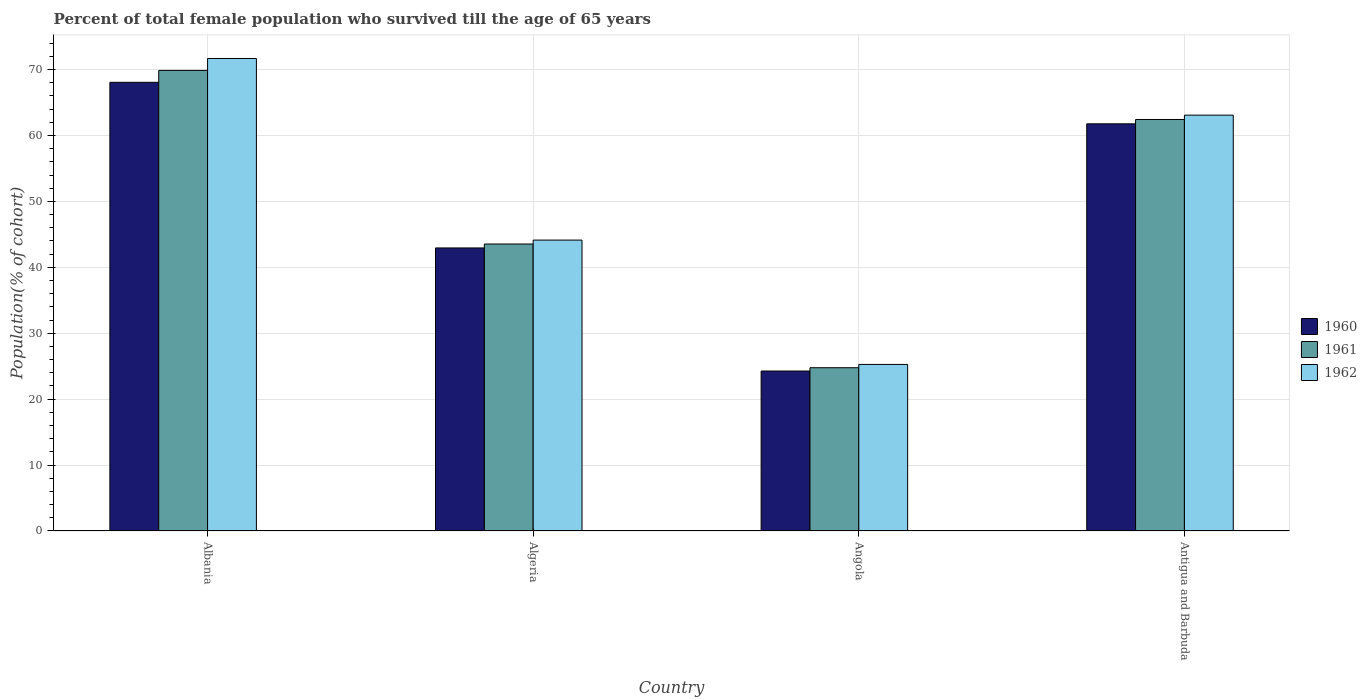Are the number of bars per tick equal to the number of legend labels?
Provide a short and direct response. Yes. How many bars are there on the 3rd tick from the right?
Offer a terse response. 3. What is the label of the 1st group of bars from the left?
Ensure brevity in your answer.  Albania. In how many cases, is the number of bars for a given country not equal to the number of legend labels?
Keep it short and to the point. 0. What is the percentage of total female population who survived till the age of 65 years in 1961 in Antigua and Barbuda?
Ensure brevity in your answer.  62.42. Across all countries, what is the maximum percentage of total female population who survived till the age of 65 years in 1960?
Give a very brief answer. 68.06. Across all countries, what is the minimum percentage of total female population who survived till the age of 65 years in 1962?
Keep it short and to the point. 25.27. In which country was the percentage of total female population who survived till the age of 65 years in 1960 maximum?
Offer a very short reply. Albania. In which country was the percentage of total female population who survived till the age of 65 years in 1960 minimum?
Your answer should be compact. Angola. What is the total percentage of total female population who survived till the age of 65 years in 1961 in the graph?
Give a very brief answer. 200.59. What is the difference between the percentage of total female population who survived till the age of 65 years in 1961 in Albania and that in Angola?
Your response must be concise. 45.1. What is the difference between the percentage of total female population who survived till the age of 65 years in 1961 in Algeria and the percentage of total female population who survived till the age of 65 years in 1962 in Albania?
Provide a succinct answer. -28.14. What is the average percentage of total female population who survived till the age of 65 years in 1960 per country?
Offer a very short reply. 49.26. What is the difference between the percentage of total female population who survived till the age of 65 years of/in 1962 and percentage of total female population who survived till the age of 65 years of/in 1961 in Angola?
Make the answer very short. 0.5. In how many countries, is the percentage of total female population who survived till the age of 65 years in 1962 greater than 46 %?
Your answer should be very brief. 2. What is the ratio of the percentage of total female population who survived till the age of 65 years in 1962 in Albania to that in Antigua and Barbuda?
Ensure brevity in your answer.  1.14. What is the difference between the highest and the second highest percentage of total female population who survived till the age of 65 years in 1961?
Your answer should be very brief. -26.34. What is the difference between the highest and the lowest percentage of total female population who survived till the age of 65 years in 1961?
Your response must be concise. 45.1. In how many countries, is the percentage of total female population who survived till the age of 65 years in 1961 greater than the average percentage of total female population who survived till the age of 65 years in 1961 taken over all countries?
Offer a very short reply. 2. Is the sum of the percentage of total female population who survived till the age of 65 years in 1960 in Albania and Algeria greater than the maximum percentage of total female population who survived till the age of 65 years in 1961 across all countries?
Provide a succinct answer. Yes. What does the 1st bar from the right in Antigua and Barbuda represents?
Your answer should be very brief. 1962. Is it the case that in every country, the sum of the percentage of total female population who survived till the age of 65 years in 1961 and percentage of total female population who survived till the age of 65 years in 1962 is greater than the percentage of total female population who survived till the age of 65 years in 1960?
Provide a short and direct response. Yes. How many bars are there?
Offer a very short reply. 12. How many countries are there in the graph?
Ensure brevity in your answer.  4. What is the difference between two consecutive major ticks on the Y-axis?
Offer a very short reply. 10. Does the graph contain any zero values?
Your answer should be very brief. No. What is the title of the graph?
Your response must be concise. Percent of total female population who survived till the age of 65 years. Does "1964" appear as one of the legend labels in the graph?
Your answer should be very brief. No. What is the label or title of the Y-axis?
Provide a succinct answer. Population(% of cohort). What is the Population(% of cohort) of 1960 in Albania?
Give a very brief answer. 68.06. What is the Population(% of cohort) in 1961 in Albania?
Your response must be concise. 69.87. What is the Population(% of cohort) of 1962 in Albania?
Your answer should be compact. 71.67. What is the Population(% of cohort) in 1960 in Algeria?
Offer a very short reply. 42.94. What is the Population(% of cohort) of 1961 in Algeria?
Your answer should be very brief. 43.53. What is the Population(% of cohort) in 1962 in Algeria?
Make the answer very short. 44.13. What is the Population(% of cohort) in 1960 in Angola?
Offer a terse response. 24.27. What is the Population(% of cohort) of 1961 in Angola?
Your answer should be compact. 24.77. What is the Population(% of cohort) in 1962 in Angola?
Offer a terse response. 25.27. What is the Population(% of cohort) in 1960 in Antigua and Barbuda?
Offer a terse response. 61.77. What is the Population(% of cohort) in 1961 in Antigua and Barbuda?
Provide a succinct answer. 62.42. What is the Population(% of cohort) in 1962 in Antigua and Barbuda?
Give a very brief answer. 63.08. Across all countries, what is the maximum Population(% of cohort) of 1960?
Your answer should be very brief. 68.06. Across all countries, what is the maximum Population(% of cohort) of 1961?
Give a very brief answer. 69.87. Across all countries, what is the maximum Population(% of cohort) in 1962?
Offer a very short reply. 71.67. Across all countries, what is the minimum Population(% of cohort) of 1960?
Your response must be concise. 24.27. Across all countries, what is the minimum Population(% of cohort) in 1961?
Your answer should be compact. 24.77. Across all countries, what is the minimum Population(% of cohort) in 1962?
Keep it short and to the point. 25.27. What is the total Population(% of cohort) in 1960 in the graph?
Provide a short and direct response. 197.04. What is the total Population(% of cohort) of 1961 in the graph?
Provide a short and direct response. 200.59. What is the total Population(% of cohort) of 1962 in the graph?
Your answer should be compact. 204.15. What is the difference between the Population(% of cohort) of 1960 in Albania and that in Algeria?
Your answer should be very brief. 25.13. What is the difference between the Population(% of cohort) of 1961 in Albania and that in Algeria?
Your answer should be very brief. 26.34. What is the difference between the Population(% of cohort) of 1962 in Albania and that in Algeria?
Offer a very short reply. 27.54. What is the difference between the Population(% of cohort) of 1960 in Albania and that in Angola?
Give a very brief answer. 43.8. What is the difference between the Population(% of cohort) in 1961 in Albania and that in Angola?
Provide a short and direct response. 45.1. What is the difference between the Population(% of cohort) of 1962 in Albania and that in Angola?
Your response must be concise. 46.41. What is the difference between the Population(% of cohort) in 1960 in Albania and that in Antigua and Barbuda?
Make the answer very short. 6.3. What is the difference between the Population(% of cohort) in 1961 in Albania and that in Antigua and Barbuda?
Provide a succinct answer. 7.45. What is the difference between the Population(% of cohort) in 1962 in Albania and that in Antigua and Barbuda?
Give a very brief answer. 8.59. What is the difference between the Population(% of cohort) in 1960 in Algeria and that in Angola?
Give a very brief answer. 18.67. What is the difference between the Population(% of cohort) of 1961 in Algeria and that in Angola?
Offer a terse response. 18.77. What is the difference between the Population(% of cohort) of 1962 in Algeria and that in Angola?
Ensure brevity in your answer.  18.86. What is the difference between the Population(% of cohort) of 1960 in Algeria and that in Antigua and Barbuda?
Make the answer very short. -18.83. What is the difference between the Population(% of cohort) in 1961 in Algeria and that in Antigua and Barbuda?
Make the answer very short. -18.89. What is the difference between the Population(% of cohort) in 1962 in Algeria and that in Antigua and Barbuda?
Your response must be concise. -18.95. What is the difference between the Population(% of cohort) in 1960 in Angola and that in Antigua and Barbuda?
Ensure brevity in your answer.  -37.5. What is the difference between the Population(% of cohort) of 1961 in Angola and that in Antigua and Barbuda?
Your answer should be compact. -37.66. What is the difference between the Population(% of cohort) of 1962 in Angola and that in Antigua and Barbuda?
Ensure brevity in your answer.  -37.82. What is the difference between the Population(% of cohort) in 1960 in Albania and the Population(% of cohort) in 1961 in Algeria?
Ensure brevity in your answer.  24.53. What is the difference between the Population(% of cohort) in 1960 in Albania and the Population(% of cohort) in 1962 in Algeria?
Provide a succinct answer. 23.93. What is the difference between the Population(% of cohort) in 1961 in Albania and the Population(% of cohort) in 1962 in Algeria?
Ensure brevity in your answer.  25.74. What is the difference between the Population(% of cohort) in 1960 in Albania and the Population(% of cohort) in 1961 in Angola?
Keep it short and to the point. 43.3. What is the difference between the Population(% of cohort) in 1960 in Albania and the Population(% of cohort) in 1962 in Angola?
Your response must be concise. 42.8. What is the difference between the Population(% of cohort) in 1961 in Albania and the Population(% of cohort) in 1962 in Angola?
Make the answer very short. 44.6. What is the difference between the Population(% of cohort) in 1960 in Albania and the Population(% of cohort) in 1961 in Antigua and Barbuda?
Provide a succinct answer. 5.64. What is the difference between the Population(% of cohort) in 1960 in Albania and the Population(% of cohort) in 1962 in Antigua and Barbuda?
Your answer should be very brief. 4.98. What is the difference between the Population(% of cohort) in 1961 in Albania and the Population(% of cohort) in 1962 in Antigua and Barbuda?
Offer a very short reply. 6.79. What is the difference between the Population(% of cohort) in 1960 in Algeria and the Population(% of cohort) in 1961 in Angola?
Give a very brief answer. 18.17. What is the difference between the Population(% of cohort) in 1960 in Algeria and the Population(% of cohort) in 1962 in Angola?
Offer a terse response. 17.67. What is the difference between the Population(% of cohort) of 1961 in Algeria and the Population(% of cohort) of 1962 in Angola?
Your answer should be very brief. 18.27. What is the difference between the Population(% of cohort) of 1960 in Algeria and the Population(% of cohort) of 1961 in Antigua and Barbuda?
Ensure brevity in your answer.  -19.49. What is the difference between the Population(% of cohort) of 1960 in Algeria and the Population(% of cohort) of 1962 in Antigua and Barbuda?
Give a very brief answer. -20.14. What is the difference between the Population(% of cohort) of 1961 in Algeria and the Population(% of cohort) of 1962 in Antigua and Barbuda?
Your response must be concise. -19.55. What is the difference between the Population(% of cohort) of 1960 in Angola and the Population(% of cohort) of 1961 in Antigua and Barbuda?
Your answer should be very brief. -38.16. What is the difference between the Population(% of cohort) in 1960 in Angola and the Population(% of cohort) in 1962 in Antigua and Barbuda?
Your answer should be very brief. -38.82. What is the difference between the Population(% of cohort) of 1961 in Angola and the Population(% of cohort) of 1962 in Antigua and Barbuda?
Your response must be concise. -38.32. What is the average Population(% of cohort) of 1960 per country?
Your answer should be compact. 49.26. What is the average Population(% of cohort) in 1961 per country?
Your response must be concise. 50.15. What is the average Population(% of cohort) of 1962 per country?
Provide a short and direct response. 51.04. What is the difference between the Population(% of cohort) of 1960 and Population(% of cohort) of 1961 in Albania?
Make the answer very short. -1.81. What is the difference between the Population(% of cohort) in 1960 and Population(% of cohort) in 1962 in Albania?
Offer a terse response. -3.61. What is the difference between the Population(% of cohort) of 1961 and Population(% of cohort) of 1962 in Albania?
Provide a short and direct response. -1.81. What is the difference between the Population(% of cohort) of 1960 and Population(% of cohort) of 1961 in Algeria?
Give a very brief answer. -0.6. What is the difference between the Population(% of cohort) in 1960 and Population(% of cohort) in 1962 in Algeria?
Provide a succinct answer. -1.19. What is the difference between the Population(% of cohort) of 1961 and Population(% of cohort) of 1962 in Algeria?
Your answer should be very brief. -0.6. What is the difference between the Population(% of cohort) of 1960 and Population(% of cohort) of 1961 in Angola?
Make the answer very short. -0.5. What is the difference between the Population(% of cohort) in 1960 and Population(% of cohort) in 1962 in Angola?
Provide a succinct answer. -1. What is the difference between the Population(% of cohort) in 1961 and Population(% of cohort) in 1962 in Angola?
Your response must be concise. -0.5. What is the difference between the Population(% of cohort) in 1960 and Population(% of cohort) in 1961 in Antigua and Barbuda?
Provide a short and direct response. -0.66. What is the difference between the Population(% of cohort) in 1960 and Population(% of cohort) in 1962 in Antigua and Barbuda?
Provide a short and direct response. -1.32. What is the difference between the Population(% of cohort) of 1961 and Population(% of cohort) of 1962 in Antigua and Barbuda?
Ensure brevity in your answer.  -0.66. What is the ratio of the Population(% of cohort) of 1960 in Albania to that in Algeria?
Your response must be concise. 1.59. What is the ratio of the Population(% of cohort) in 1961 in Albania to that in Algeria?
Your answer should be very brief. 1.6. What is the ratio of the Population(% of cohort) in 1962 in Albania to that in Algeria?
Make the answer very short. 1.62. What is the ratio of the Population(% of cohort) of 1960 in Albania to that in Angola?
Keep it short and to the point. 2.8. What is the ratio of the Population(% of cohort) of 1961 in Albania to that in Angola?
Keep it short and to the point. 2.82. What is the ratio of the Population(% of cohort) in 1962 in Albania to that in Angola?
Offer a very short reply. 2.84. What is the ratio of the Population(% of cohort) in 1960 in Albania to that in Antigua and Barbuda?
Give a very brief answer. 1.1. What is the ratio of the Population(% of cohort) of 1961 in Albania to that in Antigua and Barbuda?
Your response must be concise. 1.12. What is the ratio of the Population(% of cohort) of 1962 in Albania to that in Antigua and Barbuda?
Offer a terse response. 1.14. What is the ratio of the Population(% of cohort) in 1960 in Algeria to that in Angola?
Ensure brevity in your answer.  1.77. What is the ratio of the Population(% of cohort) in 1961 in Algeria to that in Angola?
Offer a very short reply. 1.76. What is the ratio of the Population(% of cohort) of 1962 in Algeria to that in Angola?
Your response must be concise. 1.75. What is the ratio of the Population(% of cohort) in 1960 in Algeria to that in Antigua and Barbuda?
Offer a terse response. 0.7. What is the ratio of the Population(% of cohort) in 1961 in Algeria to that in Antigua and Barbuda?
Your response must be concise. 0.7. What is the ratio of the Population(% of cohort) of 1962 in Algeria to that in Antigua and Barbuda?
Ensure brevity in your answer.  0.7. What is the ratio of the Population(% of cohort) in 1960 in Angola to that in Antigua and Barbuda?
Provide a short and direct response. 0.39. What is the ratio of the Population(% of cohort) in 1961 in Angola to that in Antigua and Barbuda?
Provide a short and direct response. 0.4. What is the ratio of the Population(% of cohort) in 1962 in Angola to that in Antigua and Barbuda?
Provide a short and direct response. 0.4. What is the difference between the highest and the second highest Population(% of cohort) of 1960?
Give a very brief answer. 6.3. What is the difference between the highest and the second highest Population(% of cohort) of 1961?
Provide a succinct answer. 7.45. What is the difference between the highest and the second highest Population(% of cohort) of 1962?
Offer a terse response. 8.59. What is the difference between the highest and the lowest Population(% of cohort) of 1960?
Your response must be concise. 43.8. What is the difference between the highest and the lowest Population(% of cohort) of 1961?
Provide a short and direct response. 45.1. What is the difference between the highest and the lowest Population(% of cohort) of 1962?
Offer a very short reply. 46.41. 